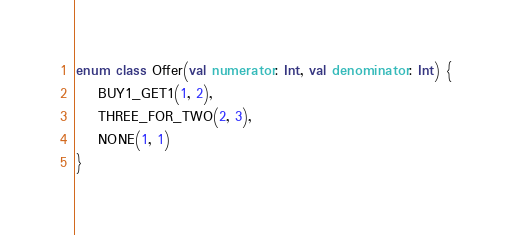<code> <loc_0><loc_0><loc_500><loc_500><_Kotlin_>enum class Offer(val numerator: Int, val denominator: Int) {
    BUY1_GET1(1, 2),
    THREE_FOR_TWO(2, 3),
    NONE(1, 1)
}
</code> 